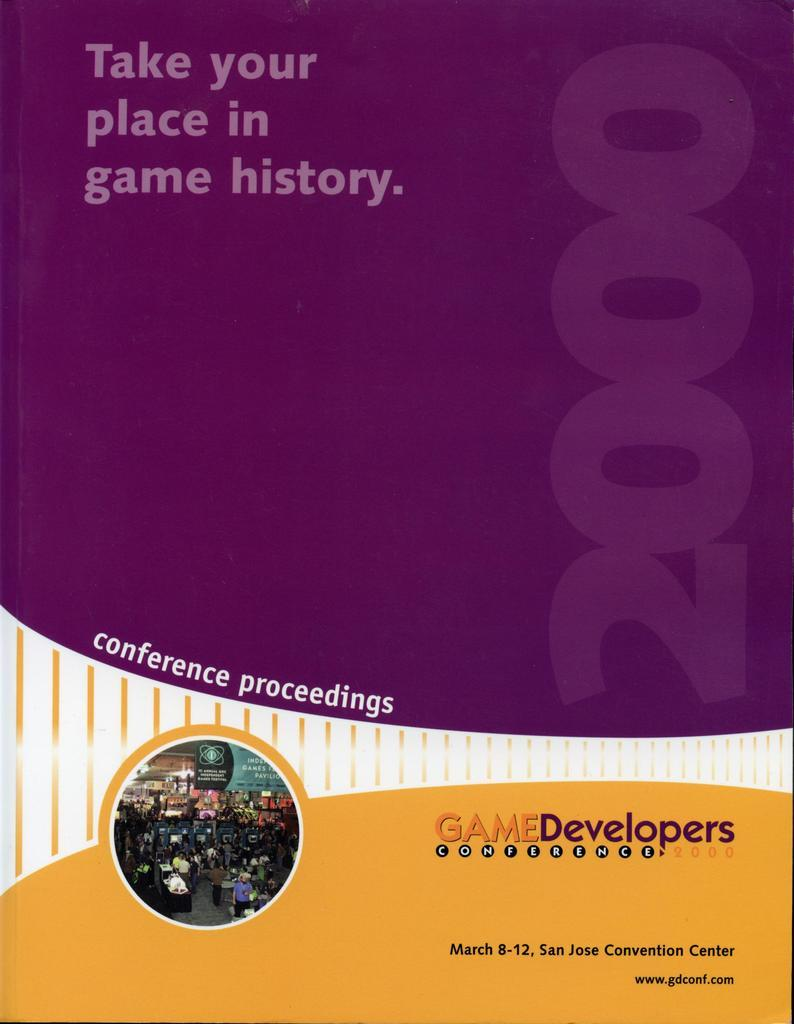<image>
Offer a succinct explanation of the picture presented. Conference proceedings book for game developers that took place in San Jose. 